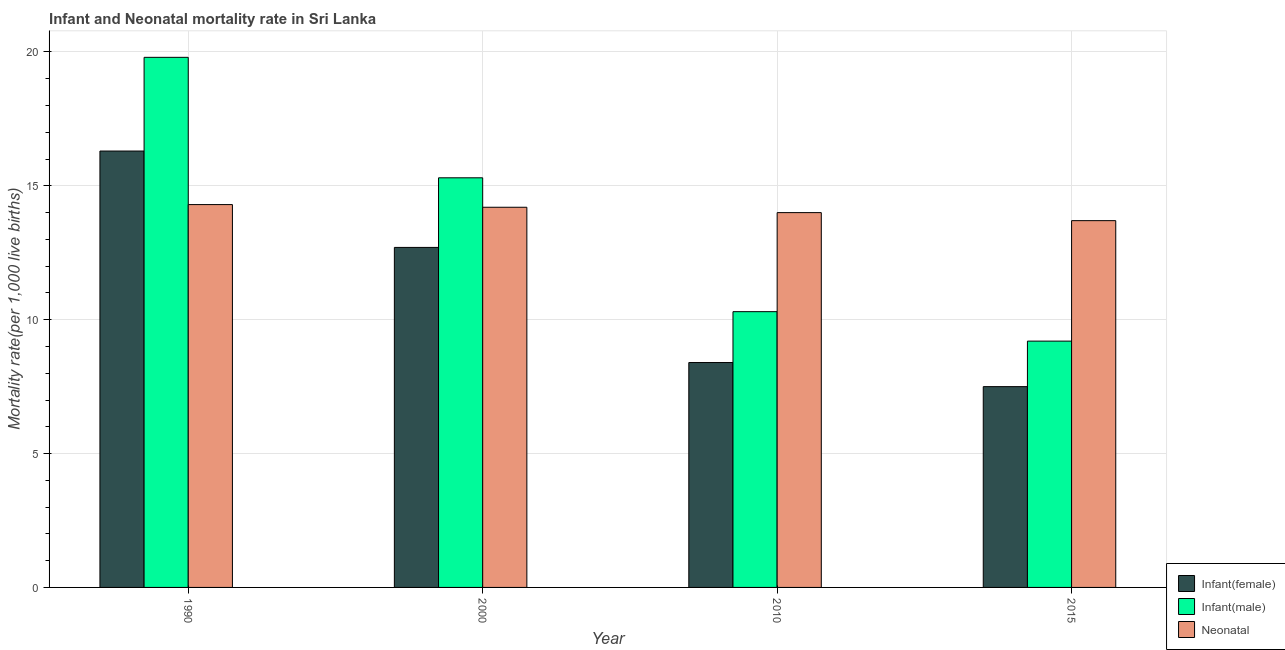Are the number of bars on each tick of the X-axis equal?
Your answer should be very brief. Yes. What is the infant mortality rate(male) in 2000?
Make the answer very short. 15.3. Across all years, what is the maximum infant mortality rate(female)?
Your answer should be compact. 16.3. In which year was the neonatal mortality rate minimum?
Provide a succinct answer. 2015. What is the total infant mortality rate(female) in the graph?
Provide a succinct answer. 44.9. What is the difference between the neonatal mortality rate in 1990 and that in 2015?
Ensure brevity in your answer.  0.6. What is the difference between the infant mortality rate(male) in 2010 and the infant mortality rate(female) in 2015?
Provide a succinct answer. 1.1. What is the average infant mortality rate(female) per year?
Ensure brevity in your answer.  11.22. What is the ratio of the infant mortality rate(male) in 2010 to that in 2015?
Offer a terse response. 1.12. Is the difference between the neonatal mortality rate in 2000 and 2015 greater than the difference between the infant mortality rate(female) in 2000 and 2015?
Ensure brevity in your answer.  No. What is the difference between the highest and the second highest infant mortality rate(female)?
Ensure brevity in your answer.  3.6. What is the difference between the highest and the lowest infant mortality rate(female)?
Give a very brief answer. 8.8. What does the 1st bar from the left in 2000 represents?
Offer a very short reply. Infant(female). What does the 3rd bar from the right in 2015 represents?
Your answer should be very brief. Infant(female). Is it the case that in every year, the sum of the infant mortality rate(female) and infant mortality rate(male) is greater than the neonatal mortality rate?
Make the answer very short. Yes. Are all the bars in the graph horizontal?
Your answer should be compact. No. Are the values on the major ticks of Y-axis written in scientific E-notation?
Give a very brief answer. No. Does the graph contain grids?
Your response must be concise. Yes. How many legend labels are there?
Your response must be concise. 3. What is the title of the graph?
Provide a short and direct response. Infant and Neonatal mortality rate in Sri Lanka. Does "Consumption Tax" appear as one of the legend labels in the graph?
Offer a terse response. No. What is the label or title of the Y-axis?
Keep it short and to the point. Mortality rate(per 1,0 live births). What is the Mortality rate(per 1,000 live births) in Infant(male) in 1990?
Ensure brevity in your answer.  19.8. What is the Mortality rate(per 1,000 live births) of Neonatal  in 1990?
Your answer should be very brief. 14.3. What is the Mortality rate(per 1,000 live births) of Infant(male) in 2010?
Make the answer very short. 10.3. What is the Mortality rate(per 1,000 live births) of Neonatal  in 2010?
Your answer should be compact. 14. What is the Mortality rate(per 1,000 live births) of Infant(female) in 2015?
Offer a very short reply. 7.5. What is the Mortality rate(per 1,000 live births) in Infant(male) in 2015?
Provide a succinct answer. 9.2. What is the Mortality rate(per 1,000 live births) in Neonatal  in 2015?
Offer a terse response. 13.7. Across all years, what is the maximum Mortality rate(per 1,000 live births) in Infant(male)?
Offer a very short reply. 19.8. Across all years, what is the maximum Mortality rate(per 1,000 live births) of Neonatal ?
Provide a succinct answer. 14.3. Across all years, what is the minimum Mortality rate(per 1,000 live births) in Infant(female)?
Your response must be concise. 7.5. Across all years, what is the minimum Mortality rate(per 1,000 live births) of Infant(male)?
Your answer should be compact. 9.2. What is the total Mortality rate(per 1,000 live births) in Infant(female) in the graph?
Offer a terse response. 44.9. What is the total Mortality rate(per 1,000 live births) of Infant(male) in the graph?
Ensure brevity in your answer.  54.6. What is the total Mortality rate(per 1,000 live births) in Neonatal  in the graph?
Make the answer very short. 56.2. What is the difference between the Mortality rate(per 1,000 live births) in Infant(male) in 1990 and that in 2000?
Provide a succinct answer. 4.5. What is the difference between the Mortality rate(per 1,000 live births) of Neonatal  in 1990 and that in 2000?
Offer a terse response. 0.1. What is the difference between the Mortality rate(per 1,000 live births) of Neonatal  in 1990 and that in 2010?
Make the answer very short. 0.3. What is the difference between the Mortality rate(per 1,000 live births) of Infant(female) in 1990 and that in 2015?
Make the answer very short. 8.8. What is the difference between the Mortality rate(per 1,000 live births) in Infant(male) in 1990 and that in 2015?
Offer a terse response. 10.6. What is the difference between the Mortality rate(per 1,000 live births) of Infant(male) in 2000 and that in 2010?
Give a very brief answer. 5. What is the difference between the Mortality rate(per 1,000 live births) of Neonatal  in 2000 and that in 2010?
Your answer should be compact. 0.2. What is the difference between the Mortality rate(per 1,000 live births) in Infant(female) in 2000 and that in 2015?
Give a very brief answer. 5.2. What is the difference between the Mortality rate(per 1,000 live births) in Infant(male) in 2010 and that in 2015?
Provide a succinct answer. 1.1. What is the difference between the Mortality rate(per 1,000 live births) in Infant(female) in 1990 and the Mortality rate(per 1,000 live births) in Infant(male) in 2000?
Your answer should be compact. 1. What is the difference between the Mortality rate(per 1,000 live births) in Infant(male) in 1990 and the Mortality rate(per 1,000 live births) in Neonatal  in 2000?
Ensure brevity in your answer.  5.6. What is the difference between the Mortality rate(per 1,000 live births) in Infant(female) in 1990 and the Mortality rate(per 1,000 live births) in Infant(male) in 2010?
Your answer should be very brief. 6. What is the difference between the Mortality rate(per 1,000 live births) in Infant(female) in 1990 and the Mortality rate(per 1,000 live births) in Neonatal  in 2015?
Make the answer very short. 2.6. What is the difference between the Mortality rate(per 1,000 live births) in Infant(male) in 2000 and the Mortality rate(per 1,000 live births) in Neonatal  in 2010?
Offer a very short reply. 1.3. What is the difference between the Mortality rate(per 1,000 live births) in Infant(female) in 2000 and the Mortality rate(per 1,000 live births) in Infant(male) in 2015?
Make the answer very short. 3.5. What is the difference between the Mortality rate(per 1,000 live births) of Infant(male) in 2000 and the Mortality rate(per 1,000 live births) of Neonatal  in 2015?
Your answer should be very brief. 1.6. What is the difference between the Mortality rate(per 1,000 live births) in Infant(male) in 2010 and the Mortality rate(per 1,000 live births) in Neonatal  in 2015?
Offer a terse response. -3.4. What is the average Mortality rate(per 1,000 live births) of Infant(female) per year?
Ensure brevity in your answer.  11.22. What is the average Mortality rate(per 1,000 live births) of Infant(male) per year?
Offer a terse response. 13.65. What is the average Mortality rate(per 1,000 live births) of Neonatal  per year?
Keep it short and to the point. 14.05. In the year 1990, what is the difference between the Mortality rate(per 1,000 live births) of Infant(female) and Mortality rate(per 1,000 live births) of Infant(male)?
Make the answer very short. -3.5. In the year 2000, what is the difference between the Mortality rate(per 1,000 live births) of Infant(male) and Mortality rate(per 1,000 live births) of Neonatal ?
Ensure brevity in your answer.  1.1. In the year 2010, what is the difference between the Mortality rate(per 1,000 live births) of Infant(female) and Mortality rate(per 1,000 live births) of Infant(male)?
Give a very brief answer. -1.9. In the year 2010, what is the difference between the Mortality rate(per 1,000 live births) in Infant(male) and Mortality rate(per 1,000 live births) in Neonatal ?
Your response must be concise. -3.7. In the year 2015, what is the difference between the Mortality rate(per 1,000 live births) of Infant(female) and Mortality rate(per 1,000 live births) of Infant(male)?
Give a very brief answer. -1.7. What is the ratio of the Mortality rate(per 1,000 live births) in Infant(female) in 1990 to that in 2000?
Provide a succinct answer. 1.28. What is the ratio of the Mortality rate(per 1,000 live births) of Infant(male) in 1990 to that in 2000?
Offer a very short reply. 1.29. What is the ratio of the Mortality rate(per 1,000 live births) in Neonatal  in 1990 to that in 2000?
Provide a short and direct response. 1.01. What is the ratio of the Mortality rate(per 1,000 live births) in Infant(female) in 1990 to that in 2010?
Give a very brief answer. 1.94. What is the ratio of the Mortality rate(per 1,000 live births) of Infant(male) in 1990 to that in 2010?
Your response must be concise. 1.92. What is the ratio of the Mortality rate(per 1,000 live births) in Neonatal  in 1990 to that in 2010?
Offer a very short reply. 1.02. What is the ratio of the Mortality rate(per 1,000 live births) in Infant(female) in 1990 to that in 2015?
Your answer should be very brief. 2.17. What is the ratio of the Mortality rate(per 1,000 live births) of Infant(male) in 1990 to that in 2015?
Your response must be concise. 2.15. What is the ratio of the Mortality rate(per 1,000 live births) of Neonatal  in 1990 to that in 2015?
Keep it short and to the point. 1.04. What is the ratio of the Mortality rate(per 1,000 live births) of Infant(female) in 2000 to that in 2010?
Provide a short and direct response. 1.51. What is the ratio of the Mortality rate(per 1,000 live births) in Infant(male) in 2000 to that in 2010?
Give a very brief answer. 1.49. What is the ratio of the Mortality rate(per 1,000 live births) of Neonatal  in 2000 to that in 2010?
Offer a very short reply. 1.01. What is the ratio of the Mortality rate(per 1,000 live births) in Infant(female) in 2000 to that in 2015?
Offer a terse response. 1.69. What is the ratio of the Mortality rate(per 1,000 live births) of Infant(male) in 2000 to that in 2015?
Offer a very short reply. 1.66. What is the ratio of the Mortality rate(per 1,000 live births) of Neonatal  in 2000 to that in 2015?
Provide a succinct answer. 1.04. What is the ratio of the Mortality rate(per 1,000 live births) in Infant(female) in 2010 to that in 2015?
Give a very brief answer. 1.12. What is the ratio of the Mortality rate(per 1,000 live births) of Infant(male) in 2010 to that in 2015?
Provide a succinct answer. 1.12. What is the ratio of the Mortality rate(per 1,000 live births) in Neonatal  in 2010 to that in 2015?
Your answer should be very brief. 1.02. What is the difference between the highest and the second highest Mortality rate(per 1,000 live births) of Infant(female)?
Provide a succinct answer. 3.6. What is the difference between the highest and the second highest Mortality rate(per 1,000 live births) in Infant(male)?
Your answer should be very brief. 4.5. What is the difference between the highest and the second highest Mortality rate(per 1,000 live births) in Neonatal ?
Provide a succinct answer. 0.1. What is the difference between the highest and the lowest Mortality rate(per 1,000 live births) of Infant(female)?
Offer a very short reply. 8.8. What is the difference between the highest and the lowest Mortality rate(per 1,000 live births) of Infant(male)?
Offer a terse response. 10.6. What is the difference between the highest and the lowest Mortality rate(per 1,000 live births) in Neonatal ?
Provide a short and direct response. 0.6. 